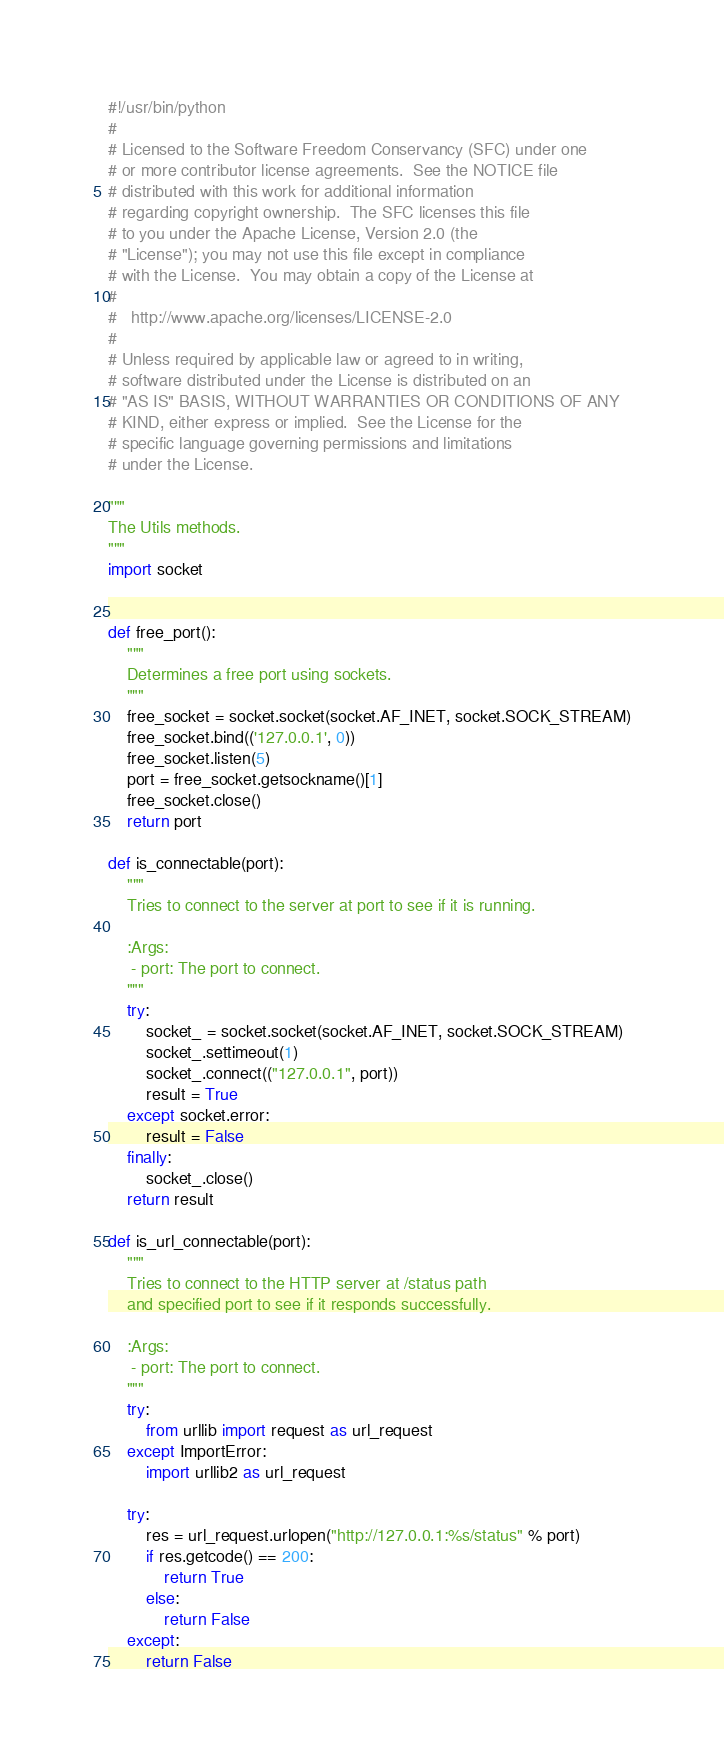<code> <loc_0><loc_0><loc_500><loc_500><_Python_>#!/usr/bin/python
#
# Licensed to the Software Freedom Conservancy (SFC) under one
# or more contributor license agreements.  See the NOTICE file
# distributed with this work for additional information
# regarding copyright ownership.  The SFC licenses this file
# to you under the Apache License, Version 2.0 (the
# "License"); you may not use this file except in compliance
# with the License.  You may obtain a copy of the License at
#
#   http://www.apache.org/licenses/LICENSE-2.0
#
# Unless required by applicable law or agreed to in writing,
# software distributed under the License is distributed on an
# "AS IS" BASIS, WITHOUT WARRANTIES OR CONDITIONS OF ANY
# KIND, either express or implied.  See the License for the
# specific language governing permissions and limitations
# under the License.

"""
The Utils methods.
"""
import socket


def free_port():
    """
    Determines a free port using sockets.
    """
    free_socket = socket.socket(socket.AF_INET, socket.SOCK_STREAM)
    free_socket.bind(('127.0.0.1', 0))
    free_socket.listen(5)
    port = free_socket.getsockname()[1]
    free_socket.close()
    return port

def is_connectable(port):
    """
    Tries to connect to the server at port to see if it is running.

    :Args:
     - port: The port to connect.
    """
    try:
        socket_ = socket.socket(socket.AF_INET, socket.SOCK_STREAM)
        socket_.settimeout(1)
        socket_.connect(("127.0.0.1", port))
        result = True
    except socket.error:
        result = False
    finally:
        socket_.close()
    return result

def is_url_connectable(port):
    """
    Tries to connect to the HTTP server at /status path
    and specified port to see if it responds successfully.

    :Args:
     - port: The port to connect.
    """
    try:
        from urllib import request as url_request
    except ImportError:
        import urllib2 as url_request

    try:
        res = url_request.urlopen("http://127.0.0.1:%s/status" % port)
        if res.getcode() == 200:
            return True
        else:
            return False
    except:
        return False
</code> 